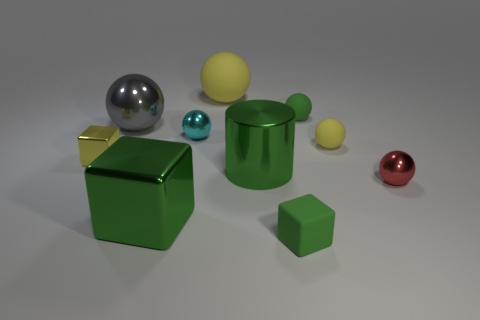The ball that is the same color as the big cylinder is what size?
Offer a very short reply. Small. Is there a small rubber sphere that has the same color as the big matte ball?
Ensure brevity in your answer.  Yes. Is the cyan metal thing the same shape as the tiny red object?
Your response must be concise. Yes. There is a big green thing that is the same shape as the yellow shiny object; what material is it?
Ensure brevity in your answer.  Metal. The tiny rubber object that is behind the big shiny block and in front of the cyan metal object is what color?
Provide a short and direct response. Yellow. The matte block is what color?
Provide a succinct answer. Green. What material is the large thing that is the same color as the big cylinder?
Give a very brief answer. Metal. Is there a gray metallic object that has the same shape as the big rubber object?
Provide a succinct answer. Yes. There is a shiny block right of the gray ball; what is its size?
Give a very brief answer. Large. There is a yellow ball that is the same size as the gray shiny sphere; what material is it?
Your response must be concise. Rubber. 